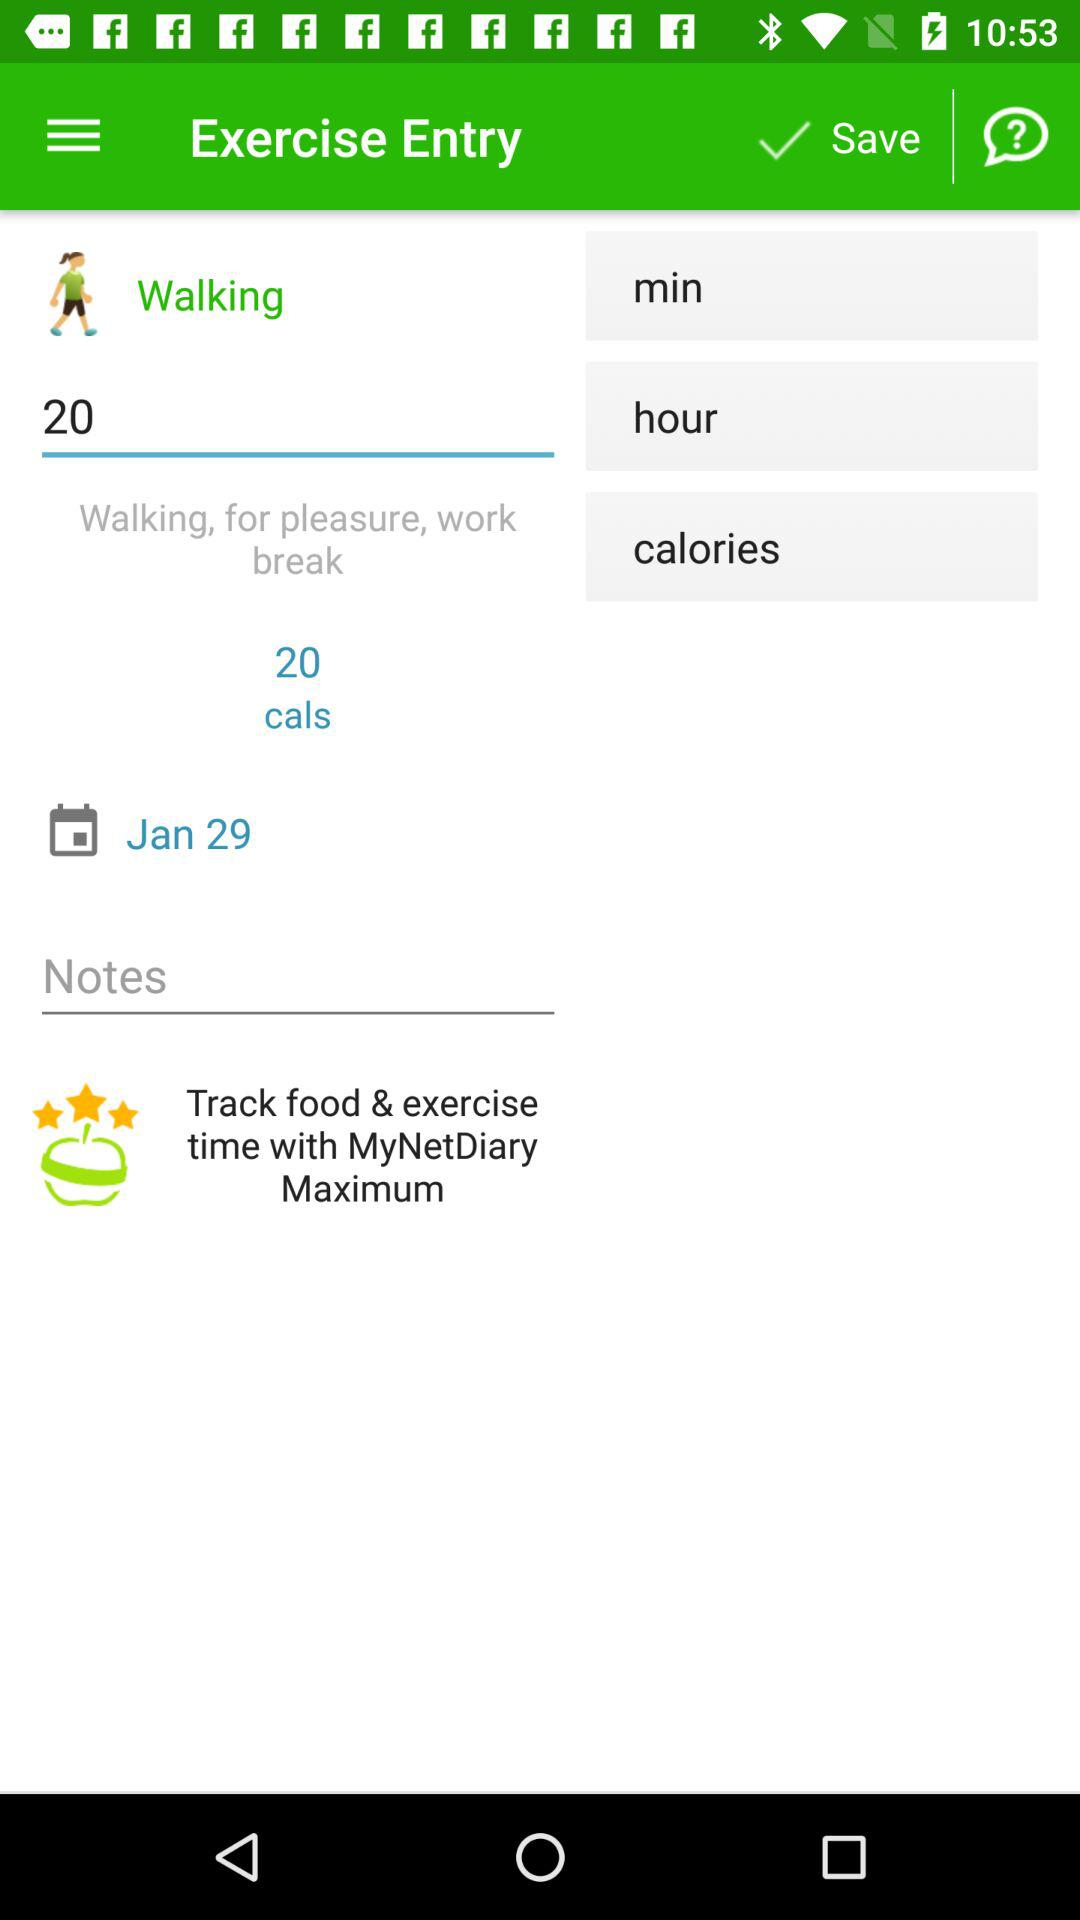How many calories are there? There are 20 calories. 